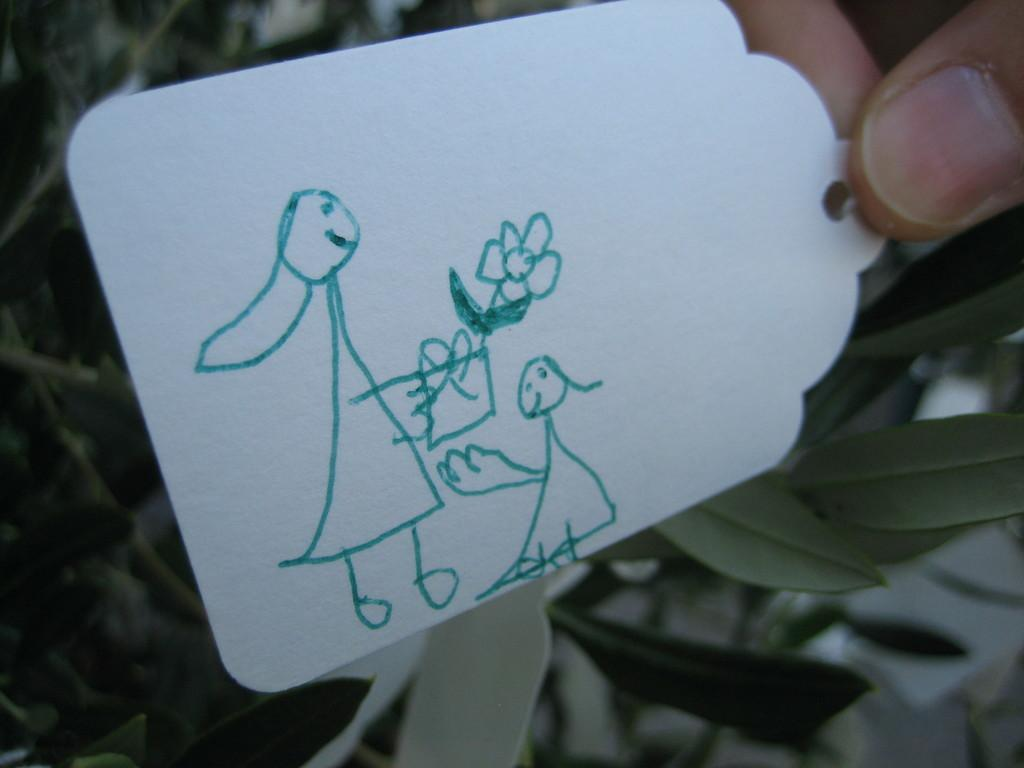What is depicted on the tag in the image? There is a picture drawn on a tag in the image. Who is holding the tag in the image? A person is holding the tag in the image. What can be seen in the background of the image? There are leaves visible in the background of the image. How many pickles are on the tag in the image? There is no mention of pickles in the image; the tag has a picture drawn on it, but the content of the picture is not specified. 